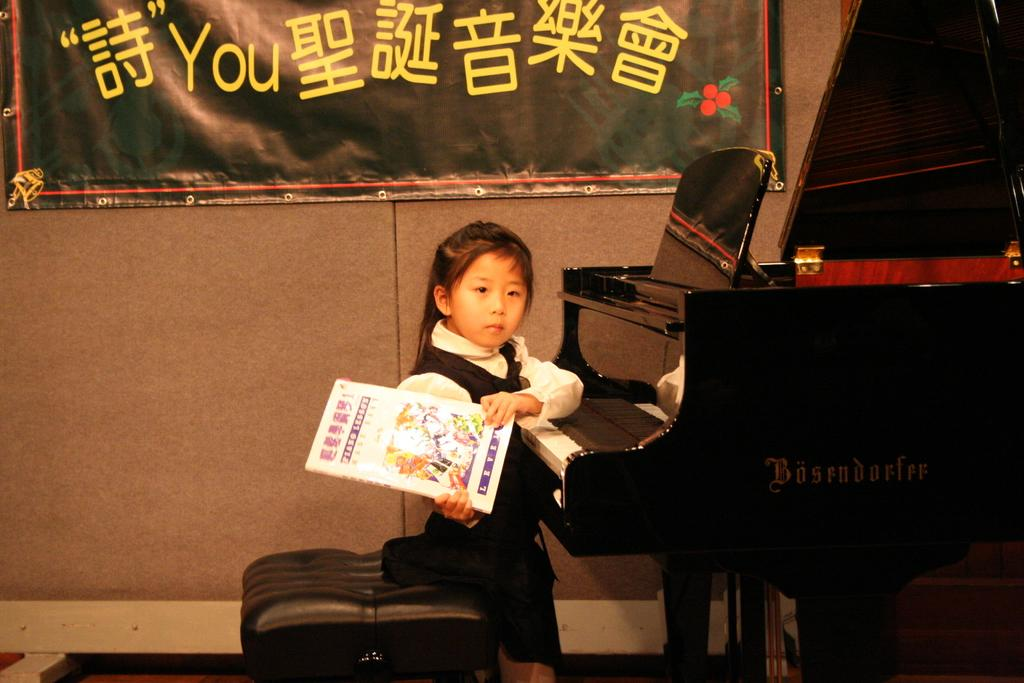What is the girl in the image doing? The girl is sitting on a stool in the image. What is the girl holding in the image? The girl is holding a book in the image. What type of musical instrument can be seen in the image? There is a piano in the image. What is hanging in the background of the image? There is a banner in the background of the image. Where is the banner attached in the image? The banner is attached to a wall in the image. Can you see any cobwebs in the image? There is no mention of cobwebs in the provided facts, and therefore we cannot determine if any are present in the image. 